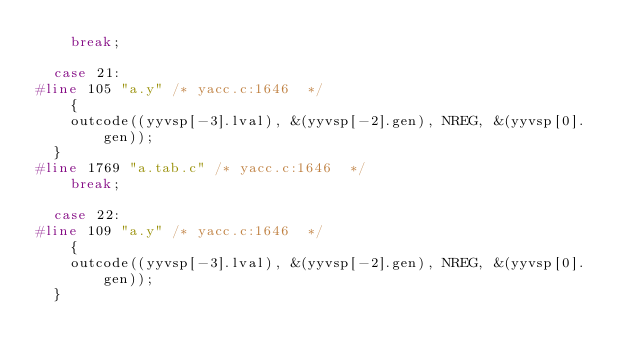<code> <loc_0><loc_0><loc_500><loc_500><_C_>    break;

  case 21:
#line 105 "a.y" /* yacc.c:1646  */
    {
		outcode((yyvsp[-3].lval), &(yyvsp[-2].gen), NREG, &(yyvsp[0].gen));
	}
#line 1769 "a.tab.c" /* yacc.c:1646  */
    break;

  case 22:
#line 109 "a.y" /* yacc.c:1646  */
    {
		outcode((yyvsp[-3].lval), &(yyvsp[-2].gen), NREG, &(yyvsp[0].gen));
	}</code> 